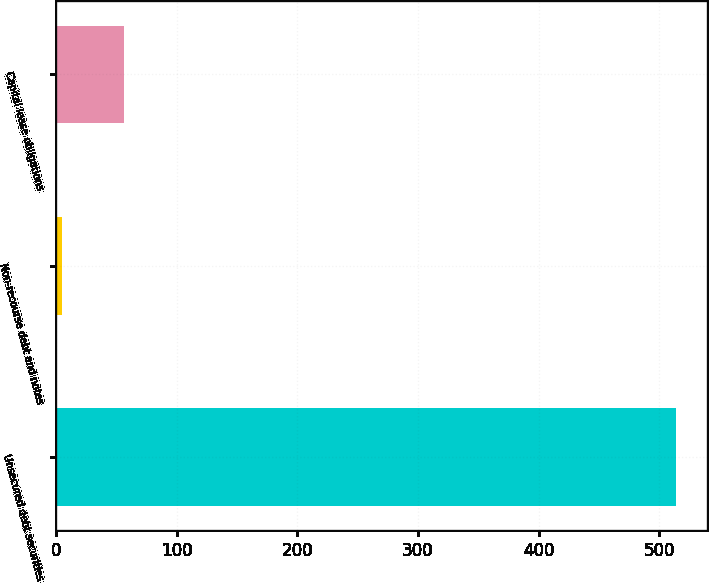Convert chart to OTSL. <chart><loc_0><loc_0><loc_500><loc_500><bar_chart><fcel>Unsecured debt securities<fcel>Non-recourse debt and notes<fcel>Capital lease obligations<nl><fcel>514<fcel>5<fcel>55.9<nl></chart> 